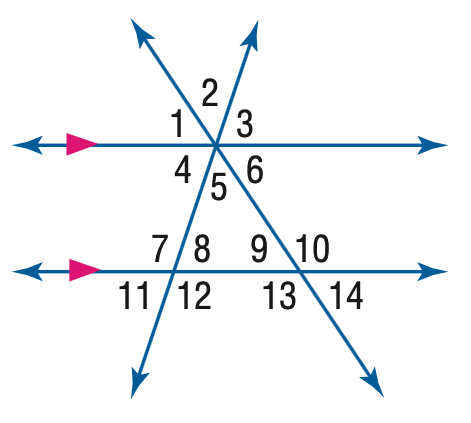Answer the mathemtical geometry problem and directly provide the correct option letter.
Question: In the figure, m \angle 11 = 62 and m \angle 14 = 38. Find the measure of \angle 10.
Choices: A: 118 B: 132 C: 132 D: 142 D 